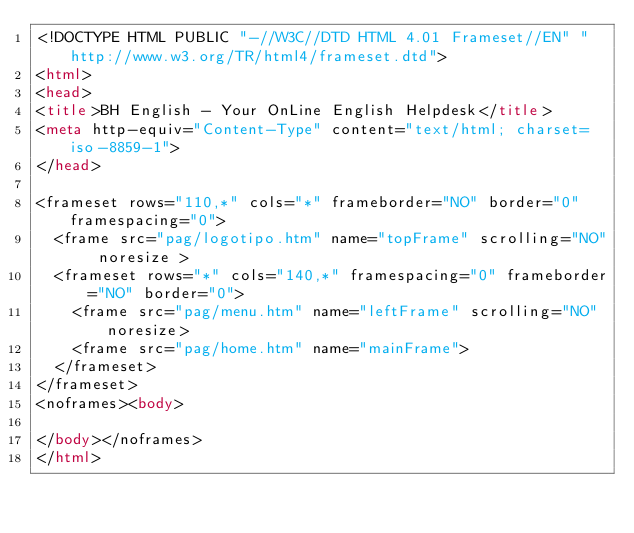Convert code to text. <code><loc_0><loc_0><loc_500><loc_500><_HTML_><!DOCTYPE HTML PUBLIC "-//W3C//DTD HTML 4.01 Frameset//EN" "http://www.w3.org/TR/html4/frameset.dtd">
<html>
<head>
<title>BH English - Your OnLine English Helpdesk</title>
<meta http-equiv="Content-Type" content="text/html; charset=iso-8859-1">
</head>

<frameset rows="110,*" cols="*" frameborder="NO" border="0" framespacing="0">
  <frame src="pag/logotipo.htm" name="topFrame" scrolling="NO" noresize >
  <frameset rows="*" cols="140,*" framespacing="0" frameborder="NO" border="0">
    <frame src="pag/menu.htm" name="leftFrame" scrolling="NO" noresize>
    <frame src="pag/home.htm" name="mainFrame">
  </frameset>
</frameset>
<noframes><body>

</body></noframes>
</html>
</code> 